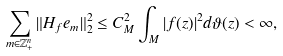<formula> <loc_0><loc_0><loc_500><loc_500>\sum _ { m \in \mathbb { Z } _ { + } ^ { n } } \| H _ { f } e _ { m } \| _ { 2 } ^ { 2 } & \leq C ^ { 2 } _ { M } \int _ { M } | f ( z ) | ^ { 2 } d \vartheta ( z ) < \infty ,</formula> 